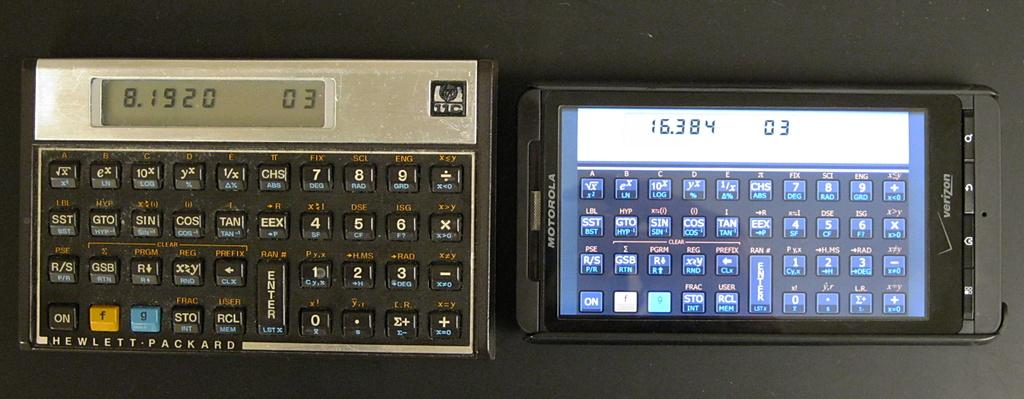<image>
Summarize the visual content of the image. two old looking screens, the left of which has the word 15384 on the top 